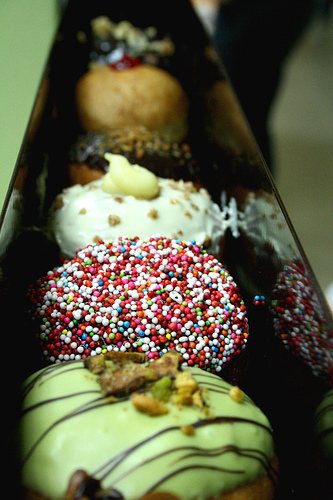What flavors might these doughnuts be? The flavors of these doughnuts could include chocolate with sprinkles, possibly a vanilla frosted one with multi-colored nonpareils, one that might be glaze-frosted with green drizzle suggesting a pistachio or mint flavor, and another that appears to have some nut toppings which could indicate a maple or caramel flavor. 